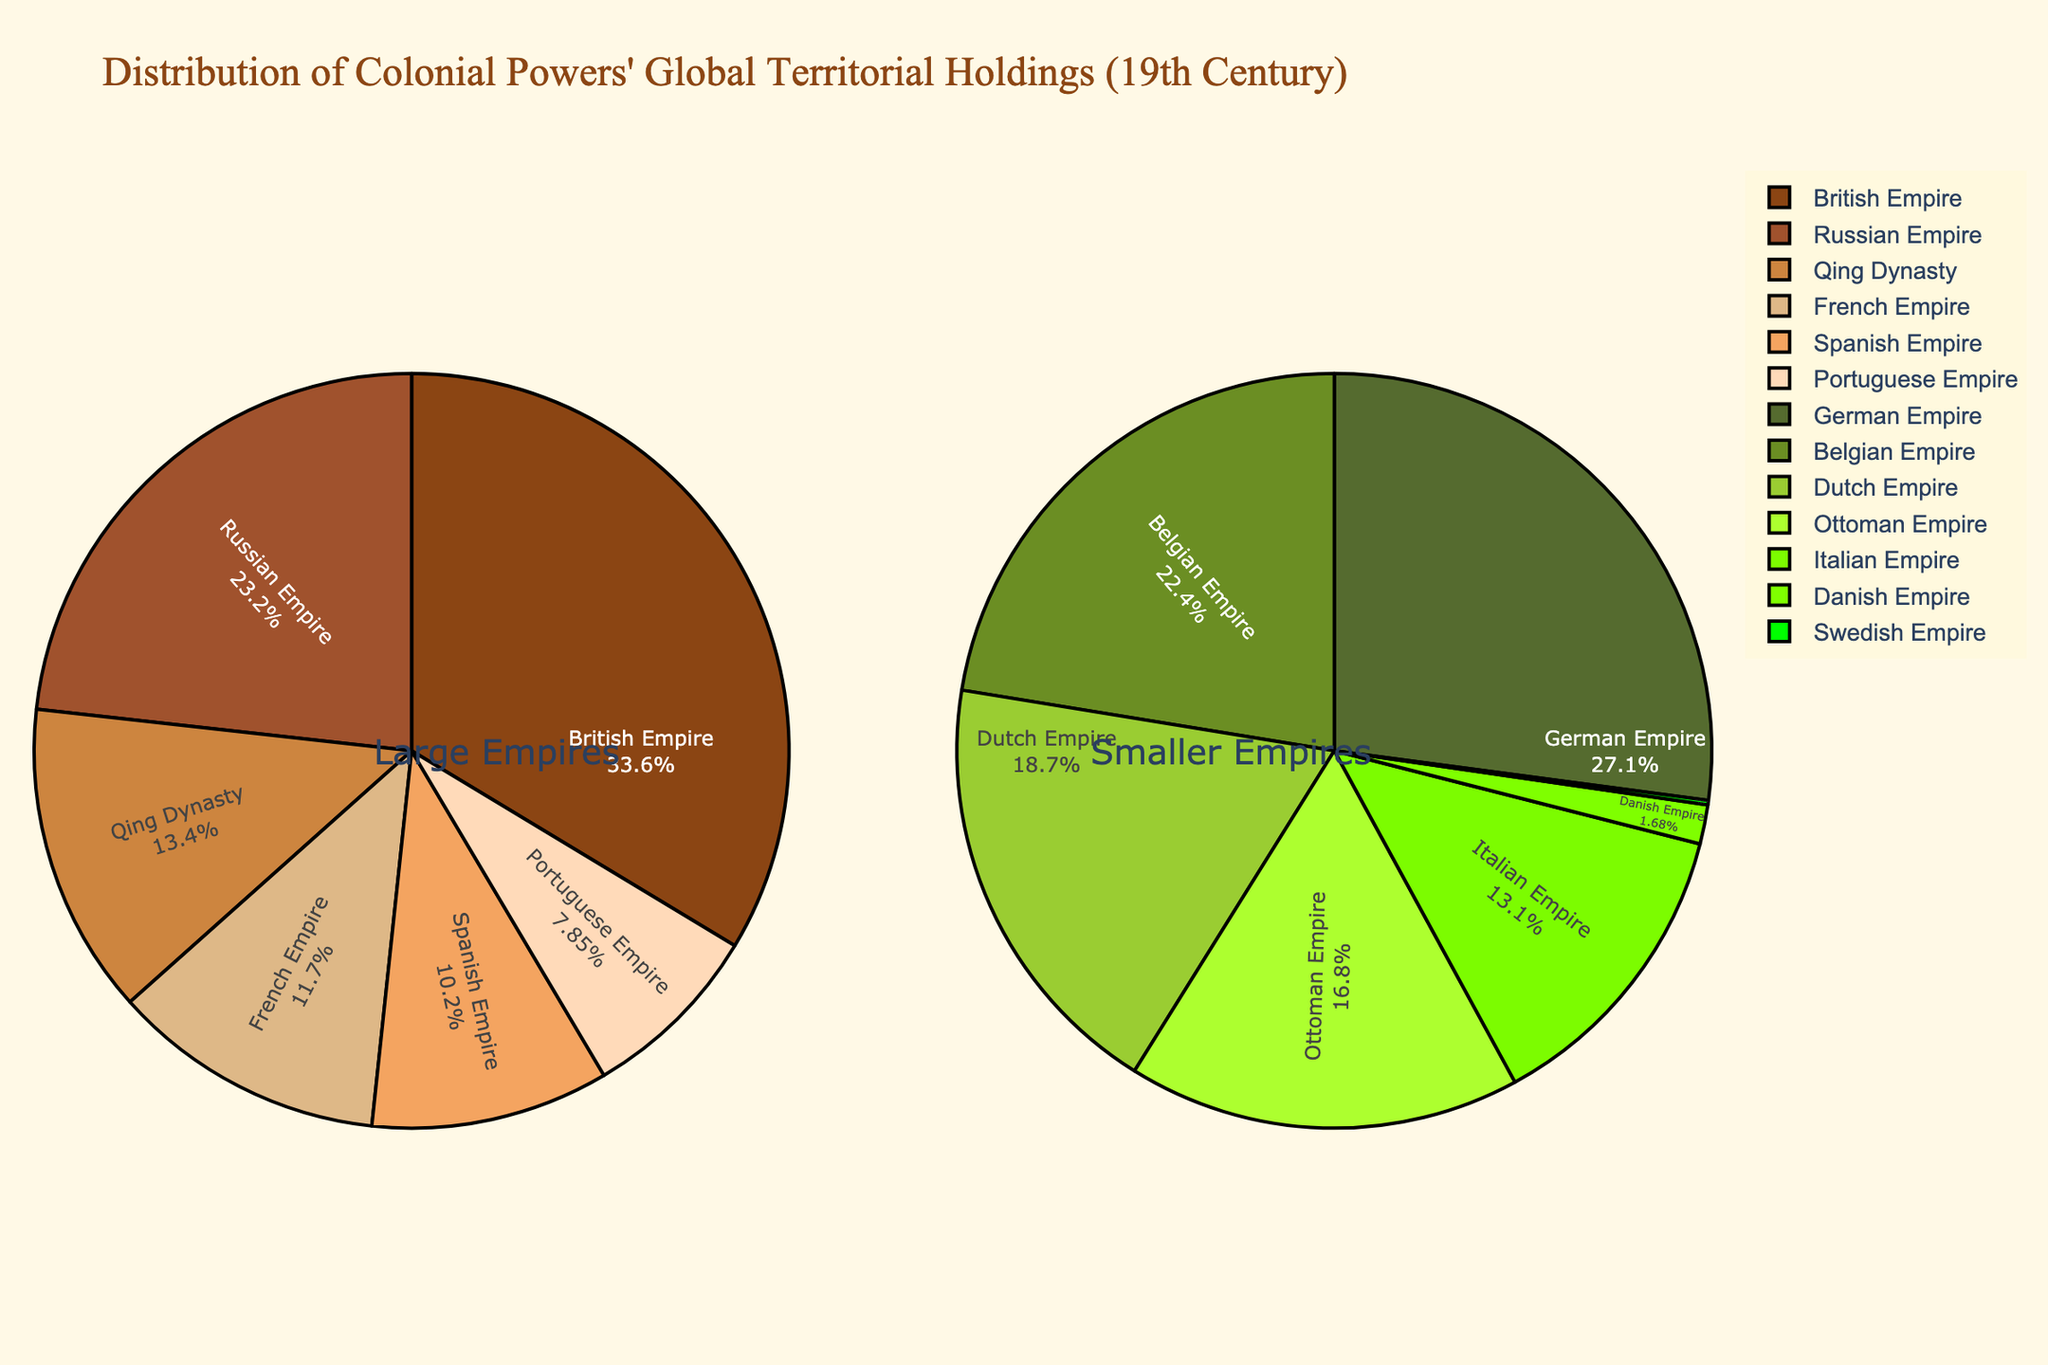Which empire held the largest territorial area in the 19th century? The "Large Empires" pie chart shows that the British Empire has the largest slice, indicating it held the largest territorial area.
Answer: British Empire How does the land area of the Qing Dynasty compare to that of the Spanish Empire? By looking at the slices in the "Large Empires" section, the Qing Dynasty's slice appears larger than the Spanish Empire's, meaning the Qing Dynasty had a larger land area.
Answer: Qing Dynasty is larger What percentage of the global territorial holdings did the Russian Empire occupy? The "Large Empires" pie chart indicates the percentage for the Russian Empire by its label inside the slice.
Answer: 24.8% Which two smaller empires had the smallest land areas, and what were their percentages? The "Smaller Empires" pie chart shows that the Danish Empire and Swedish Empire have the smallest slices, with percentages labeled inside the slices.
Answer: Danish Empire with 0.3% and Swedish Empire with 0.03% If you combine the areas of the Ottoman Empire, German Empire, and Belgian Empire, how does their combined area compare to that of the French Empire? Locate the slices for the Ottoman Empire (1,800,000 sq km), German Empire (2,900,000 sq km), and Belgian Empire (2,400,000 sq km) and sum these values to compare with the French Empire (11,500,000 sq km). The combined area is 7,100,000 sq km, which is smaller than the French Empire's area.
Answer: Smaller What color represents the French Empire's territory in the pie chart? Look at the "Large Empires" pie chart and identify the color used for the French Empire's slice.
Answer: A shade of brown (#CD853F) What is the combined percentage of the British Empire and Russian Empire's territorial holdings? Sum the percentages inside the slices for the British Empire (35.9%) and Russian Empire (24.8%) from the "Large Empires" pie chart.
Answer: 60.7% Among the smaller empires, which one has a slice closest to 7% of the global territorial holdings? Examine the "Smaller Empires" pie chart to find the slice labeled closest to 7%, which is the Portuguese Empire.
Answer: Portuguese Empire What is the difference in land area between the Dutch Empire and the German Empire? Look at the respective slices in the "Smaller Empires" pie chart and subtract the Dutch Empire's area (2,000,000 sq km) from the German Empire's area (2,900,000 sq km).
Answer: 900,000 sq km larger for German Empire What proportion of the total land area of the French Empire and British Empire combined does the French Empire alone represent? Add the land areas of the French Empire (11,500,000 sq km) and British Empire (33,000,000 sq km) to get the total combined land area (44,500,000 sq km). Then, divide the French Empire's area by this total and multiply by 100 to get the proportion in percentage.
Answer: 25.8% 